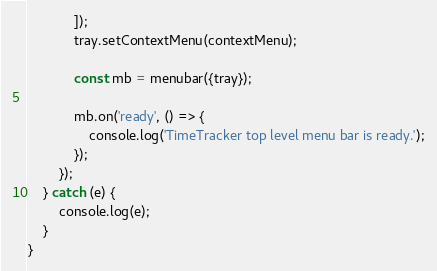<code> <loc_0><loc_0><loc_500><loc_500><_TypeScript_>            ]);
            tray.setContextMenu(contextMenu);

            const mb = menubar({tray});

            mb.on('ready', () => {
                console.log('TimeTracker top level menu bar is ready.');
            });
        });
    } catch (e) {
        console.log(e);
    }
}
</code> 